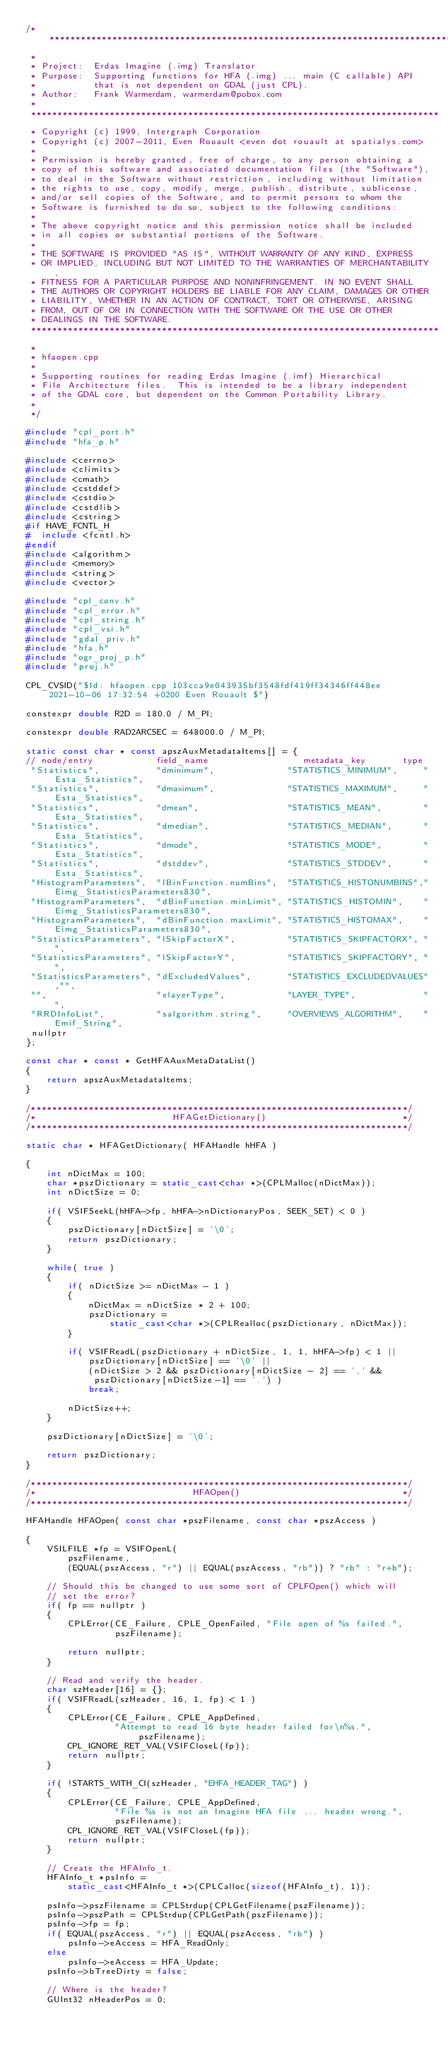Convert code to text. <code><loc_0><loc_0><loc_500><loc_500><_C++_>/******************************************************************************
 *
 * Project:  Erdas Imagine (.img) Translator
 * Purpose:  Supporting functions for HFA (.img) ... main (C callable) API
 *           that is not dependent on GDAL (just CPL).
 * Author:   Frank Warmerdam, warmerdam@pobox.com
 *
 ******************************************************************************
 * Copyright (c) 1999, Intergraph Corporation
 * Copyright (c) 2007-2011, Even Rouault <even dot rouault at spatialys.com>
 *
 * Permission is hereby granted, free of charge, to any person obtaining a
 * copy of this software and associated documentation files (the "Software"),
 * to deal in the Software without restriction, including without limitation
 * the rights to use, copy, modify, merge, publish, distribute, sublicense,
 * and/or sell copies of the Software, and to permit persons to whom the
 * Software is furnished to do so, subject to the following conditions:
 *
 * The above copyright notice and this permission notice shall be included
 * in all copies or substantial portions of the Software.
 *
 * THE SOFTWARE IS PROVIDED "AS IS", WITHOUT WARRANTY OF ANY KIND, EXPRESS
 * OR IMPLIED, INCLUDING BUT NOT LIMITED TO THE WARRANTIES OF MERCHANTABILITY,
 * FITNESS FOR A PARTICULAR PURPOSE AND NONINFRINGEMENT. IN NO EVENT SHALL
 * THE AUTHORS OR COPYRIGHT HOLDERS BE LIABLE FOR ANY CLAIM, DAMAGES OR OTHER
 * LIABILITY, WHETHER IN AN ACTION OF CONTRACT, TORT OR OTHERWISE, ARISING
 * FROM, OUT OF OR IN CONNECTION WITH THE SOFTWARE OR THE USE OR OTHER
 * DEALINGS IN THE SOFTWARE.
 ******************************************************************************
 *
 * hfaopen.cpp
 *
 * Supporting routines for reading Erdas Imagine (.imf) Hierarchical
 * File Architecture files.  This is intended to be a library independent
 * of the GDAL core, but dependent on the Common Portability Library.
 *
 */

#include "cpl_port.h"
#include "hfa_p.h"

#include <cerrno>
#include <climits>
#include <cmath>
#include <cstddef>
#include <cstdio>
#include <cstdlib>
#include <cstring>
#if HAVE_FCNTL_H
#  include <fcntl.h>
#endif
#include <algorithm>
#include <memory>
#include <string>
#include <vector>

#include "cpl_conv.h"
#include "cpl_error.h"
#include "cpl_string.h"
#include "cpl_vsi.h"
#include "gdal_priv.h"
#include "hfa.h"
#include "ogr_proj_p.h"
#include "proj.h"

CPL_CVSID("$Id: hfaopen.cpp 103cca9e043935bf3548fdf419ff34346ff448ee 2021-10-06 17:32:54 +0200 Even Rouault $")

constexpr double R2D = 180.0 / M_PI;

constexpr double RAD2ARCSEC = 648000.0 / M_PI;

static const char * const apszAuxMetadataItems[] = {
// node/entry            field_name                  metadata_key       type
 "Statistics",           "dminimum",              "STATISTICS_MINIMUM",     "Esta_Statistics",
 "Statistics",           "dmaximum",              "STATISTICS_MAXIMUM",     "Esta_Statistics",
 "Statistics",           "dmean",                 "STATISTICS_MEAN",        "Esta_Statistics",
 "Statistics",           "dmedian",               "STATISTICS_MEDIAN",      "Esta_Statistics",
 "Statistics",           "dmode",                 "STATISTICS_MODE",        "Esta_Statistics",
 "Statistics",           "dstddev",               "STATISTICS_STDDEV",      "Esta_Statistics",
 "HistogramParameters",  "lBinFunction.numBins",  "STATISTICS_HISTONUMBINS","Eimg_StatisticsParameters830",
 "HistogramParameters",  "dBinFunction.minLimit", "STATISTICS_HISTOMIN",    "Eimg_StatisticsParameters830",
 "HistogramParameters",  "dBinFunction.maxLimit", "STATISTICS_HISTOMAX",    "Eimg_StatisticsParameters830",
 "StatisticsParameters", "lSkipFactorX",          "STATISTICS_SKIPFACTORX", "",
 "StatisticsParameters", "lSkipFactorY",          "STATISTICS_SKIPFACTORY", "",
 "StatisticsParameters", "dExcludedValues",       "STATISTICS_EXCLUDEDVALUES","",
 "",                     "elayerType",            "LAYER_TYPE",             "",
 "RRDInfoList",          "salgorithm.string",     "OVERVIEWS_ALGORITHM",    "Emif_String",
 nullptr
};

const char * const * GetHFAAuxMetaDataList()
{
    return apszAuxMetadataItems;
}

/************************************************************************/
/*                          HFAGetDictionary()                          */
/************************************************************************/

static char * HFAGetDictionary( HFAHandle hHFA )

{
    int nDictMax = 100;
    char *pszDictionary = static_cast<char *>(CPLMalloc(nDictMax));
    int nDictSize = 0;

    if( VSIFSeekL(hHFA->fp, hHFA->nDictionaryPos, SEEK_SET) < 0 )
    {
        pszDictionary[nDictSize] = '\0';
        return pszDictionary;
    }

    while( true )
    {
        if( nDictSize >= nDictMax - 1 )
        {
            nDictMax = nDictSize * 2 + 100;
            pszDictionary =
                static_cast<char *>(CPLRealloc(pszDictionary, nDictMax));
        }

        if( VSIFReadL(pszDictionary + nDictSize, 1, 1, hHFA->fp) < 1 ||
            pszDictionary[nDictSize] == '\0' ||
            (nDictSize > 2 && pszDictionary[nDictSize - 2] == ',' &&
             pszDictionary[nDictSize-1] == '.') )
            break;

        nDictSize++;
    }

    pszDictionary[nDictSize] = '\0';

    return pszDictionary;
}

/************************************************************************/
/*                              HFAOpen()                               */
/************************************************************************/

HFAHandle HFAOpen( const char *pszFilename, const char *pszAccess )

{
    VSILFILE *fp = VSIFOpenL(
        pszFilename,
        (EQUAL(pszAccess, "r") || EQUAL(pszAccess, "rb")) ? "rb" : "r+b");

    // Should this be changed to use some sort of CPLFOpen() which will
    // set the error?
    if( fp == nullptr )
    {
        CPLError(CE_Failure, CPLE_OpenFailed, "File open of %s failed.",
                 pszFilename);

        return nullptr;
    }

    // Read and verify the header.
    char szHeader[16] = {};
    if( VSIFReadL(szHeader, 16, 1, fp) < 1 )
    {
        CPLError(CE_Failure, CPLE_AppDefined,
                 "Attempt to read 16 byte header failed for\n%s.", pszFilename);
        CPL_IGNORE_RET_VAL(VSIFCloseL(fp));
        return nullptr;
    }

    if( !STARTS_WITH_CI(szHeader, "EHFA_HEADER_TAG") )
    {
        CPLError(CE_Failure, CPLE_AppDefined,
                 "File %s is not an Imagine HFA file ... header wrong.",
                 pszFilename);
        CPL_IGNORE_RET_VAL(VSIFCloseL(fp));
        return nullptr;
    }

    // Create the HFAInfo_t.
    HFAInfo_t *psInfo =
        static_cast<HFAInfo_t *>(CPLCalloc(sizeof(HFAInfo_t), 1));

    psInfo->pszFilename = CPLStrdup(CPLGetFilename(pszFilename));
    psInfo->pszPath = CPLStrdup(CPLGetPath(pszFilename));
    psInfo->fp = fp;
    if( EQUAL(pszAccess, "r") || EQUAL(pszAccess, "rb") )
        psInfo->eAccess = HFA_ReadOnly;
    else
        psInfo->eAccess = HFA_Update;
    psInfo->bTreeDirty = false;

    // Where is the header?
    GUInt32 nHeaderPos = 0;</code> 